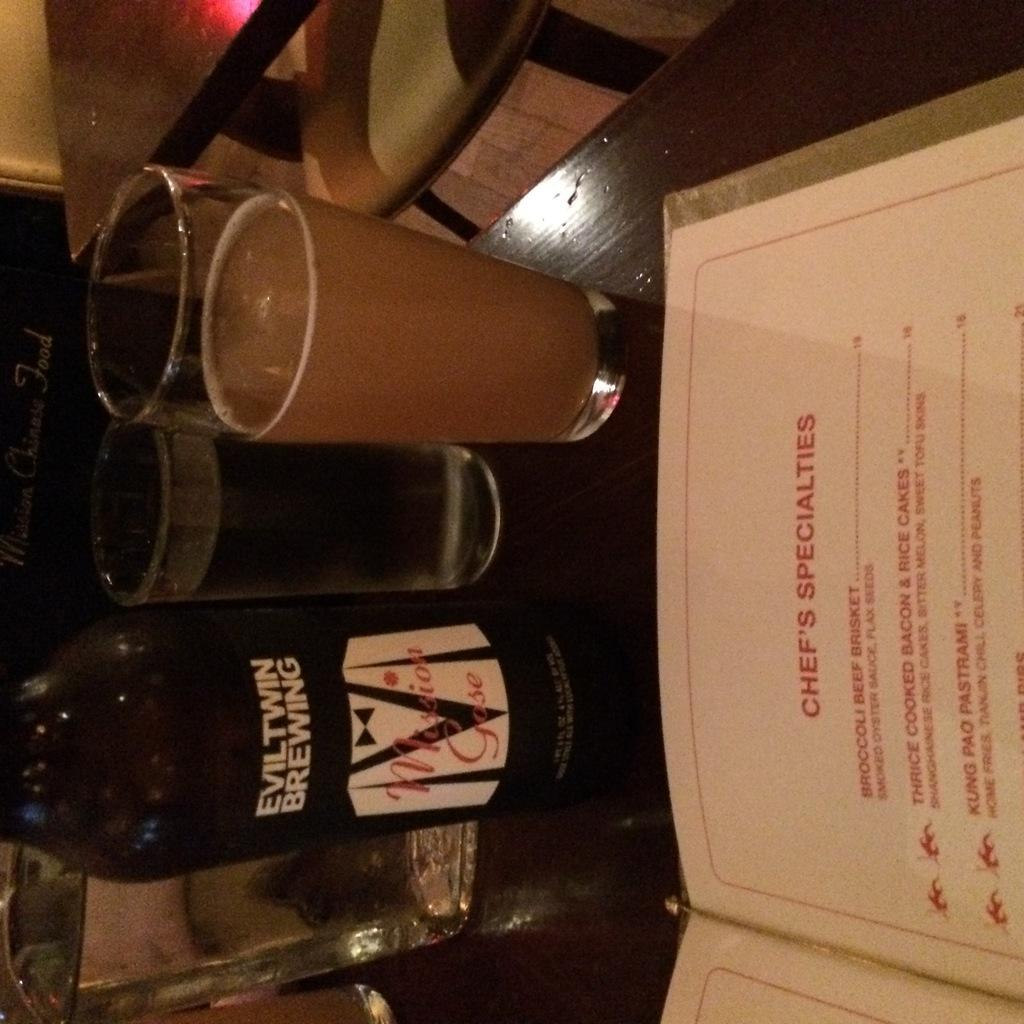What type of furniture is present in the image? There is a table in the image. What is placed on the table? There are three glasses of drinks on the table. Are there any other items on the table besides the glasses? Yes, there are two bottles on the table. What might be used to make a selection of food or drinks in the image? There is a menu card on the table. Can you see any other tables in the image? Yes, there is another table visible in the image. What is the size of the baby in the image? There is no baby present in the image. 